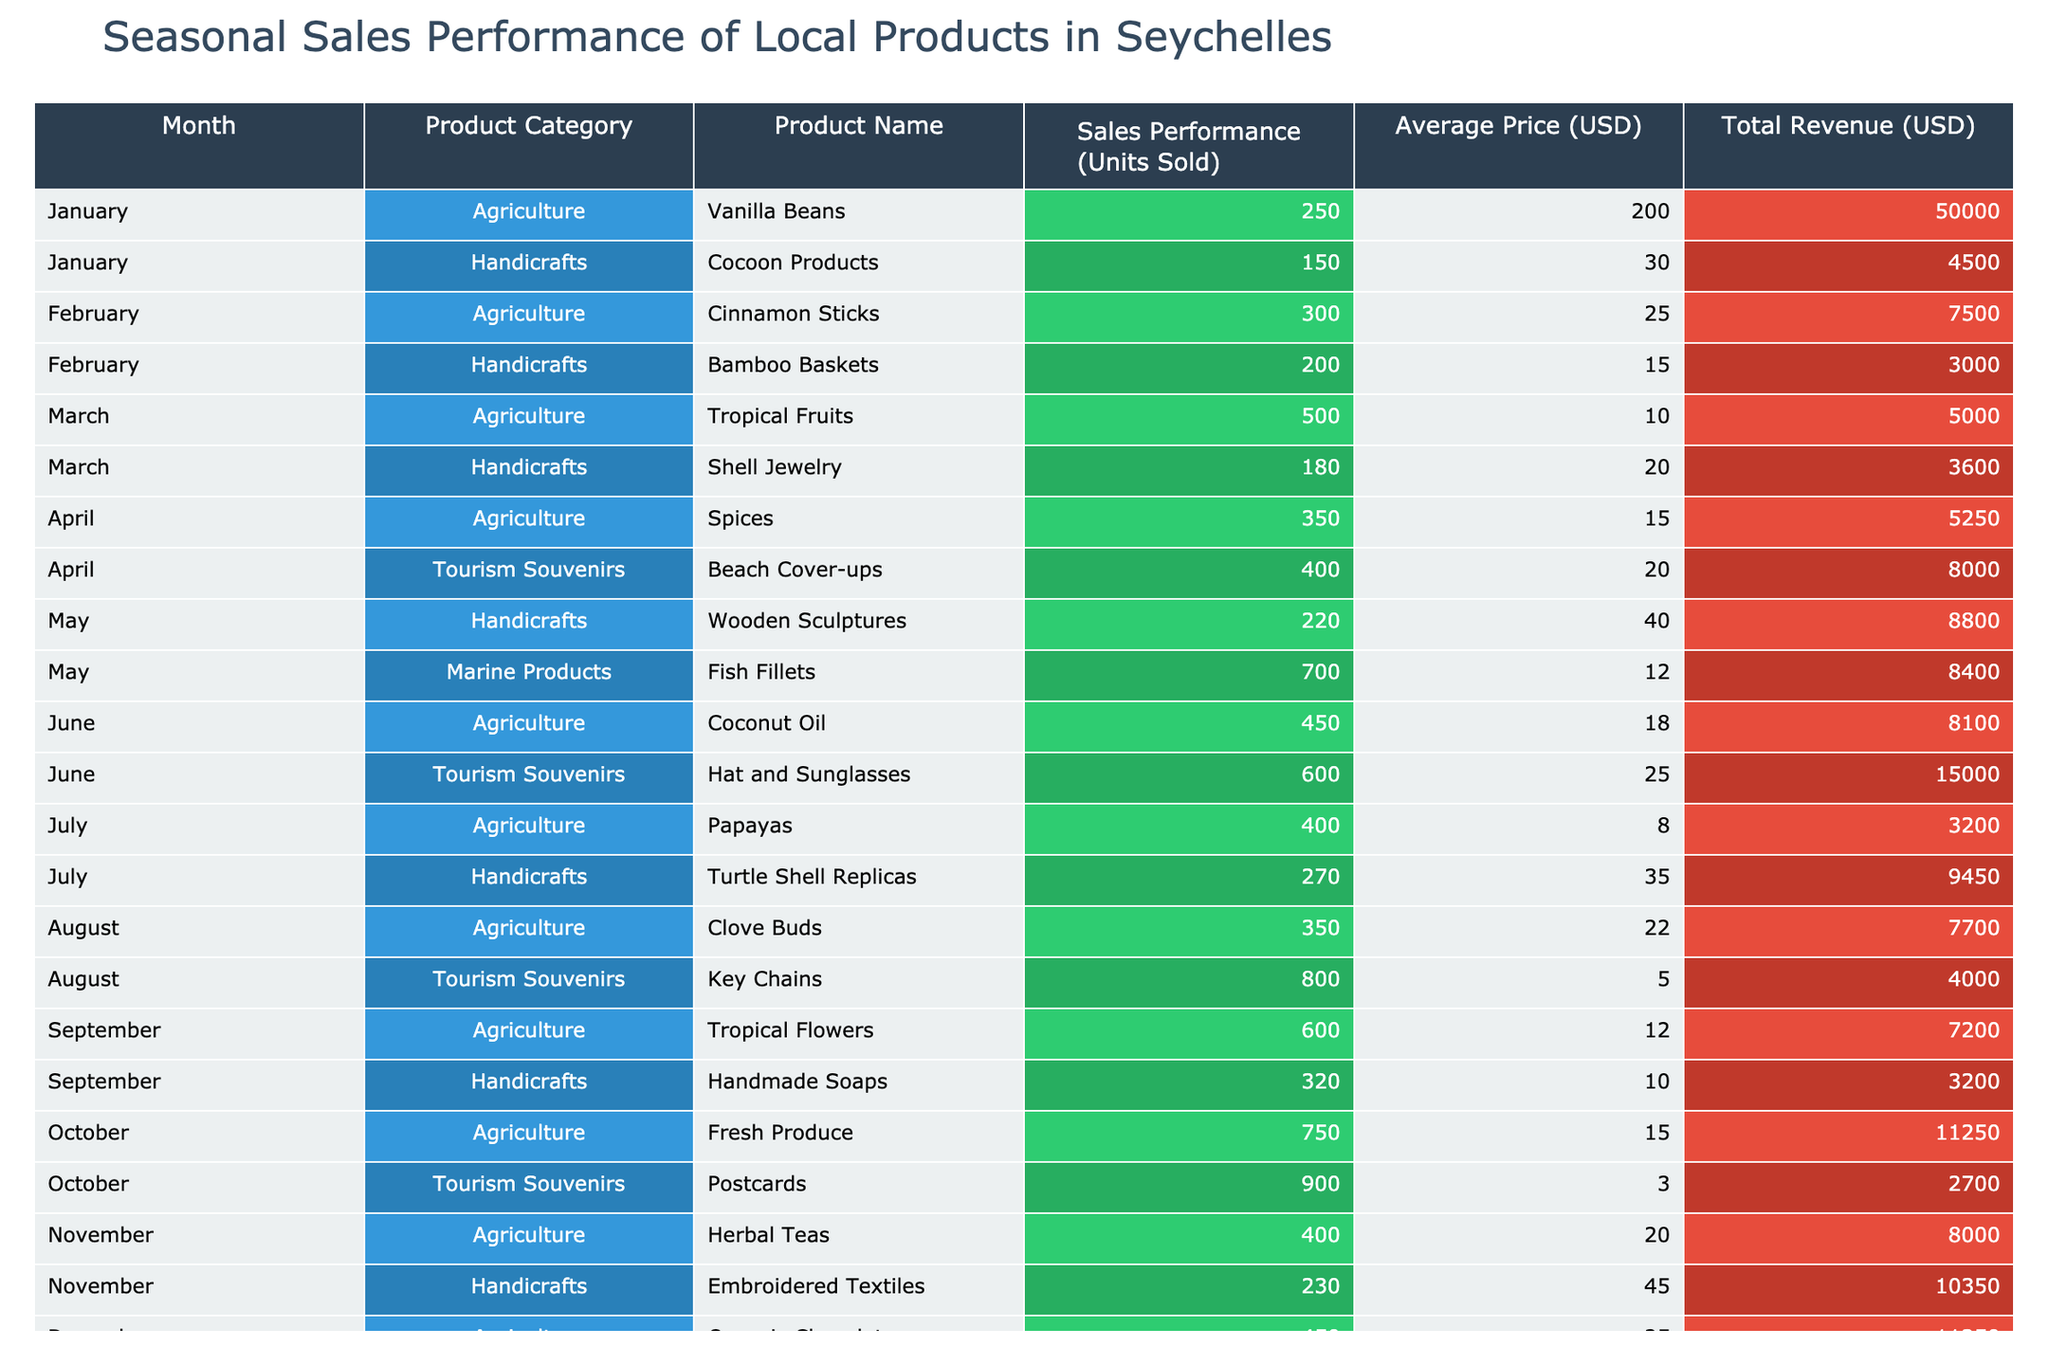What is the total revenue generated by marine products in May? In May, the only marine product listed is Fish Fillets. The total revenue for Fish Fillets is 8400 USD. Hence, the total revenue for marine products in May is simply the total revenue for Fish Fillets.
Answer: 8400 USD Which product category had the highest sales performance in October? In October, the Agriculture category had 750 units sold for Fresh Produce, while Tourism Souvenirs had 900 units sold for Postcards. The highest sales performance in October belongs to the Tourism Souvenirs category with 900 units sold.
Answer: Tourism Souvenirs How many units of Handicrafts were sold in total throughout the year? Adding the units sold for each Handicrafts product across all months: Cocoon Products (150) + Bamboo Baskets (200) + Shell Jewelry (180) + Wooden Sculptures (220) + Turtle Shell Replicas (270) + Handmade Soaps (320) + Embroidered Textiles (230). This totals to 1,570 units sold for Handicrafts.
Answer: 1570 units Did the sales performance for Agriculture products increase from January to December? In January, the total sales for Agriculture products were 250 (Vanilla Beans) + 0 + 0 + 0 + 0 + 0 + 0 + 0 + 0 + 0 + 0 + 0 = 250 units. In December, it was 450 (Organic Chocolates). Thus, comparing January's sales to December's, it shows an increase from 250 to 450 units.
Answer: Yes Which month had the highest overall revenue, and what was that revenue? To find this, we need to calculate the total revenue for each month by summing the revenues for all products listed in that month. The maximum revenue was in December with 15,000 USD from Christmas Ornaments, and 11,250 USD from Organic Chocolates, yielding a total of 26,250 USD, which is the highest overall revenue.
Answer: 26250 USD 